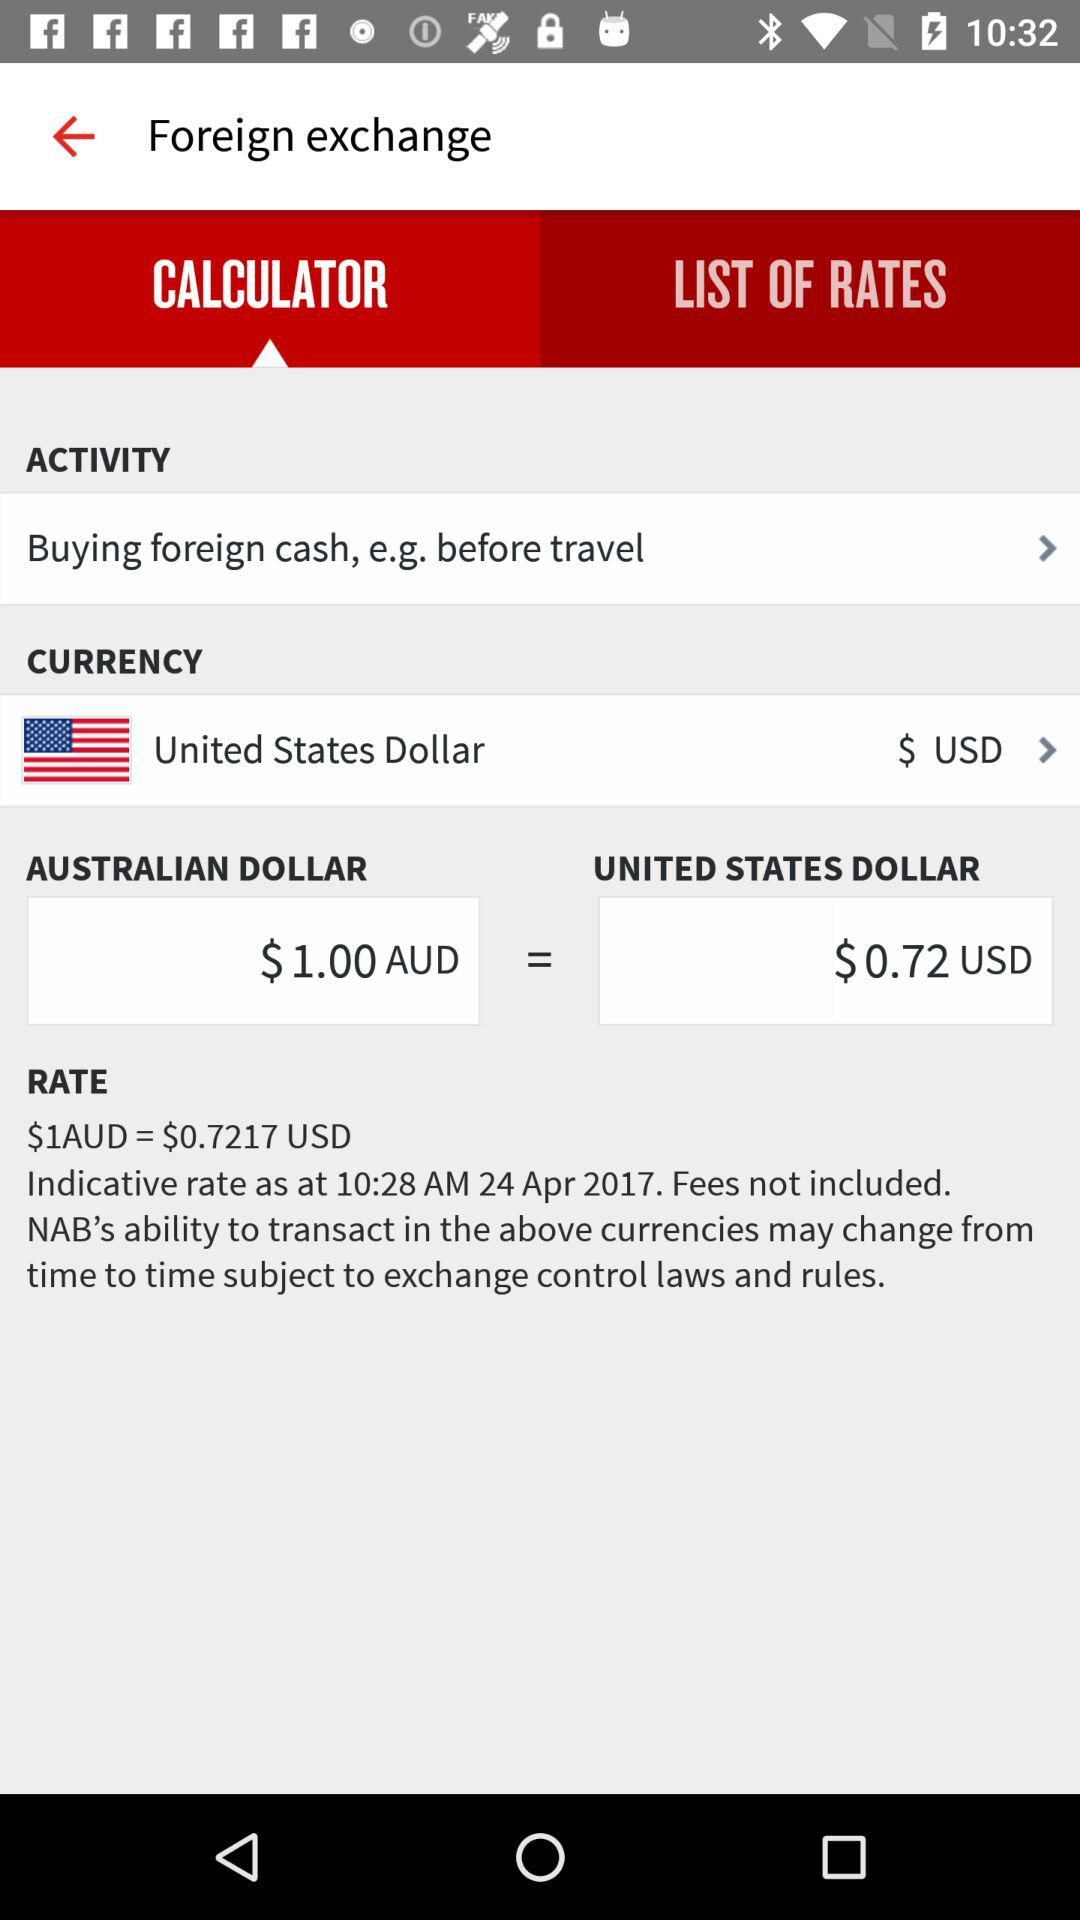Which option has been selected? The selected options are "CALCULATOR", "Buying foreign cash, e.g. before travel" and "$ USD". 